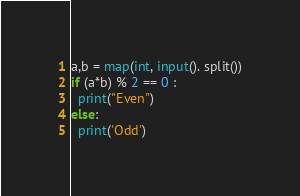Convert code to text. <code><loc_0><loc_0><loc_500><loc_500><_Python_>a,b = map(int, input(). split())
if (a*b) % 2 == 0 :
  print("Even")
else:
  print('Odd')</code> 